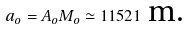Convert formula to latex. <formula><loc_0><loc_0><loc_500><loc_500>a _ { o } = A _ { o } M _ { o } \simeq 1 1 5 2 1 \text { m.}</formula> 